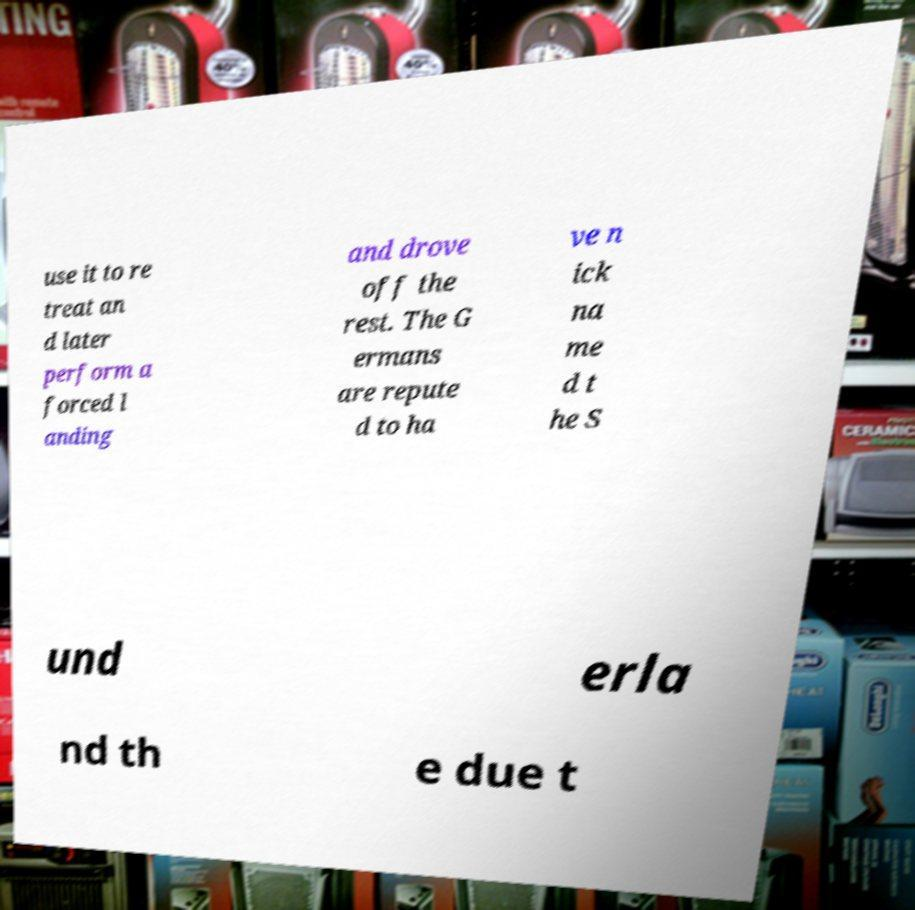Can you read and provide the text displayed in the image?This photo seems to have some interesting text. Can you extract and type it out for me? use it to re treat an d later perform a forced l anding and drove off the rest. The G ermans are repute d to ha ve n ick na me d t he S und erla nd th e due t 